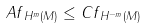Convert formula to latex. <formula><loc_0><loc_0><loc_500><loc_500>\| A f \| _ { H ^ { m } ( M ) } \leq C \| f \| _ { H ^ { - m } ( M ) }</formula> 